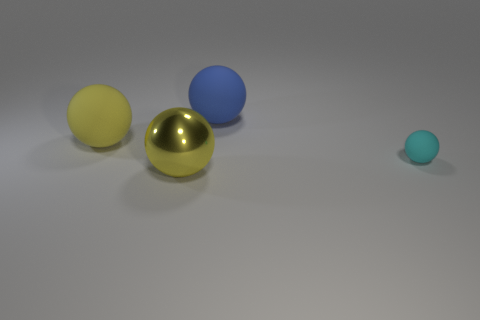Are there an equal number of big yellow matte balls that are on the right side of the large metal object and large cyan rubber things?
Keep it short and to the point. Yes. How many other things are the same color as the small object?
Give a very brief answer. 0. Are there fewer big blue matte things that are on the left side of the shiny object than small cyan matte balls?
Offer a terse response. Yes. Is there a yellow rubber sphere of the same size as the cyan object?
Your answer should be compact. No. Is the color of the small sphere the same as the ball that is in front of the small cyan rubber object?
Make the answer very short. No. What number of yellow shiny balls are left of the big rubber ball that is in front of the large blue thing?
Your answer should be very brief. 0. There is a thing behind the matte ball on the left side of the big blue rubber ball; what is its color?
Your answer should be very brief. Blue. What material is the sphere that is on the right side of the yellow rubber sphere and behind the small cyan rubber ball?
Offer a very short reply. Rubber. Are there any other blue things that have the same shape as the large blue thing?
Offer a terse response. No. There is a thing that is right of the blue matte sphere; is it the same shape as the metal object?
Your answer should be very brief. Yes. 